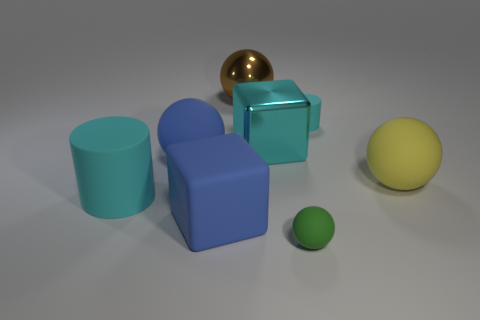Subtract 1 spheres. How many spheres are left? 3 Subtract all cylinders. How many objects are left? 6 Subtract all rubber cylinders. Subtract all tiny gray matte things. How many objects are left? 6 Add 3 matte blocks. How many matte blocks are left? 4 Add 1 small cyan metallic balls. How many small cyan metallic balls exist? 1 Subtract 0 green cylinders. How many objects are left? 8 